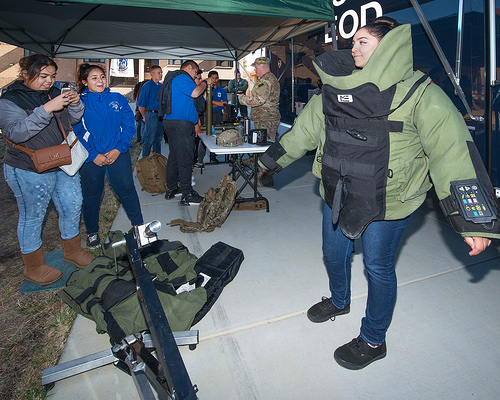<image>
Is there a woman on the floor? Yes. Looking at the image, I can see the woman is positioned on top of the floor, with the floor providing support. 